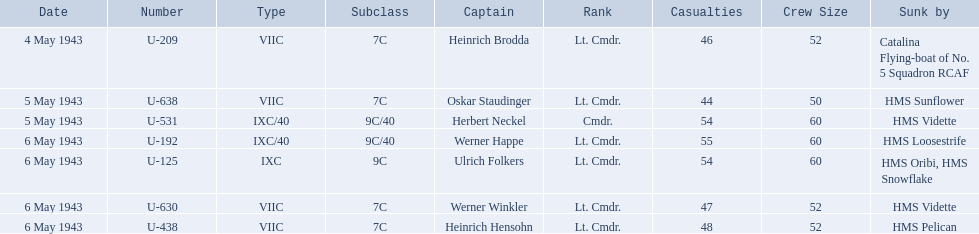Who are the captains of the u boats? Heinrich Brodda, Oskar Staudinger, Herbert Neckel, Werner Happe, Ulrich Folkers, Werner Winkler, Heinrich Hensohn. What are the dates the u boat captains were lost? 4 May 1943, 5 May 1943, 5 May 1943, 6 May 1943, 6 May 1943, 6 May 1943, 6 May 1943. Of these, which were lost on may 5? Oskar Staudinger, Herbert Neckel. Other than oskar staudinger, who else was lost on this day? Herbert Neckel. 